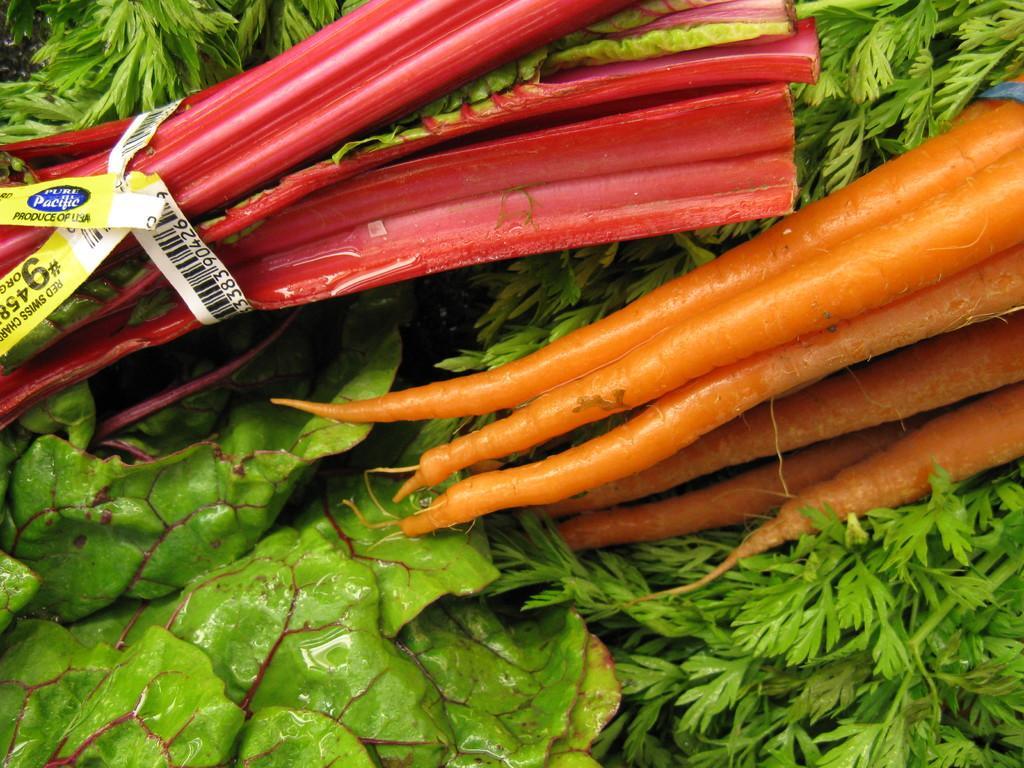In one or two sentences, can you explain what this image depicts? In this picture I can observe vegetables. There are leafy vegetables and carrots which are in orange color. 